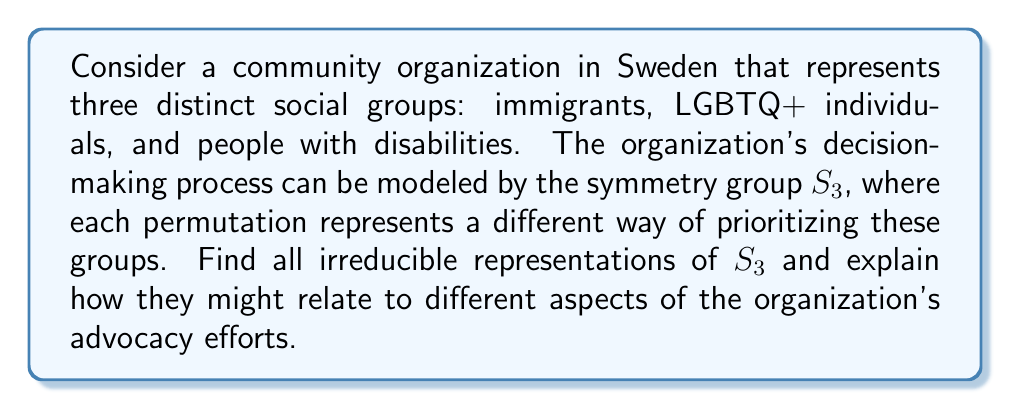Provide a solution to this math problem. To find the irreducible representations of $S_3$, we'll follow these steps:

1) First, recall that the number of irreducible representations is equal to the number of conjugacy classes. $S_3$ has 3 conjugacy classes:
   - Identity: $\{e\}$
   - Transpositions: $\{(12), (23), (13)\}$
   - 3-cycles: $\{(123), (132)\}$

2) The sum of squares of dimensions of irreducible representations equals the order of the group. Let's call the dimensions $d_1$, $d_2$, and $d_3$. Then:
   
   $d_1^2 + d_2^2 + d_3^2 = |S_3| = 6$

3) We know there's always a trivial representation of dimension 1. So $d_1 = 1$.

4) There's also always a sign representation for $S_n$, which is 1-dimensional. So $d_2 = 1$.

5) From step 2, we can now deduce that $d_3 = 2$.

6) The trivial representation $\rho_1$ maps every element to 1:
   
   $\rho_1(g) = 1$ for all $g \in S_3$

7) The sign representation $\rho_2$ maps even permutations to 1 and odd permutations to -1:
   
   $\rho_2(e) = \rho_2((123)) = \rho_2((132)) = 1$
   $\rho_2((12)) = \rho_2((23)) = \rho_2((13)) = -1$

8) For the 2-dimensional representation $\rho_3$, we can use the fact that the character of $(123)$ must be $-1$ (as the sum of all characters of $(123)$ across all irreducible representations must be 0). We can represent $\rho_3$ as:

   $\rho_3(e) = \begin{pmatrix} 1 & 0 \\ 0 & 1 \end{pmatrix}$
   
   $\rho_3((12)) = \begin{pmatrix} -1/2 & \sqrt{3}/2 \\ \sqrt{3}/2 & 1/2 \end{pmatrix}$
   
   $\rho_3((123)) = \begin{pmatrix} -1/2 & -\sqrt{3}/2 \\ \sqrt{3}/2 & -1/2 \end{pmatrix}$

These representations could relate to the organization's advocacy efforts as follows:
- $\rho_1$: Represents unified action where all groups are treated equally.
- $\rho_2$: Represents a focus on whether an action benefits an odd or even number of groups.
- $\rho_3$: Represents more complex interactions and trade-offs between the three groups.
Answer: $\rho_1$ (trivial), $\rho_2$ (sign), $\rho_3$ (2-dimensional) 